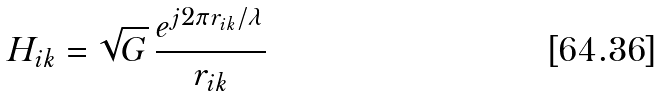<formula> <loc_0><loc_0><loc_500><loc_500>H _ { i k } = \sqrt { G } \, \frac { e ^ { j 2 \pi r _ { i k } / \lambda } } { r _ { i k } }</formula> 